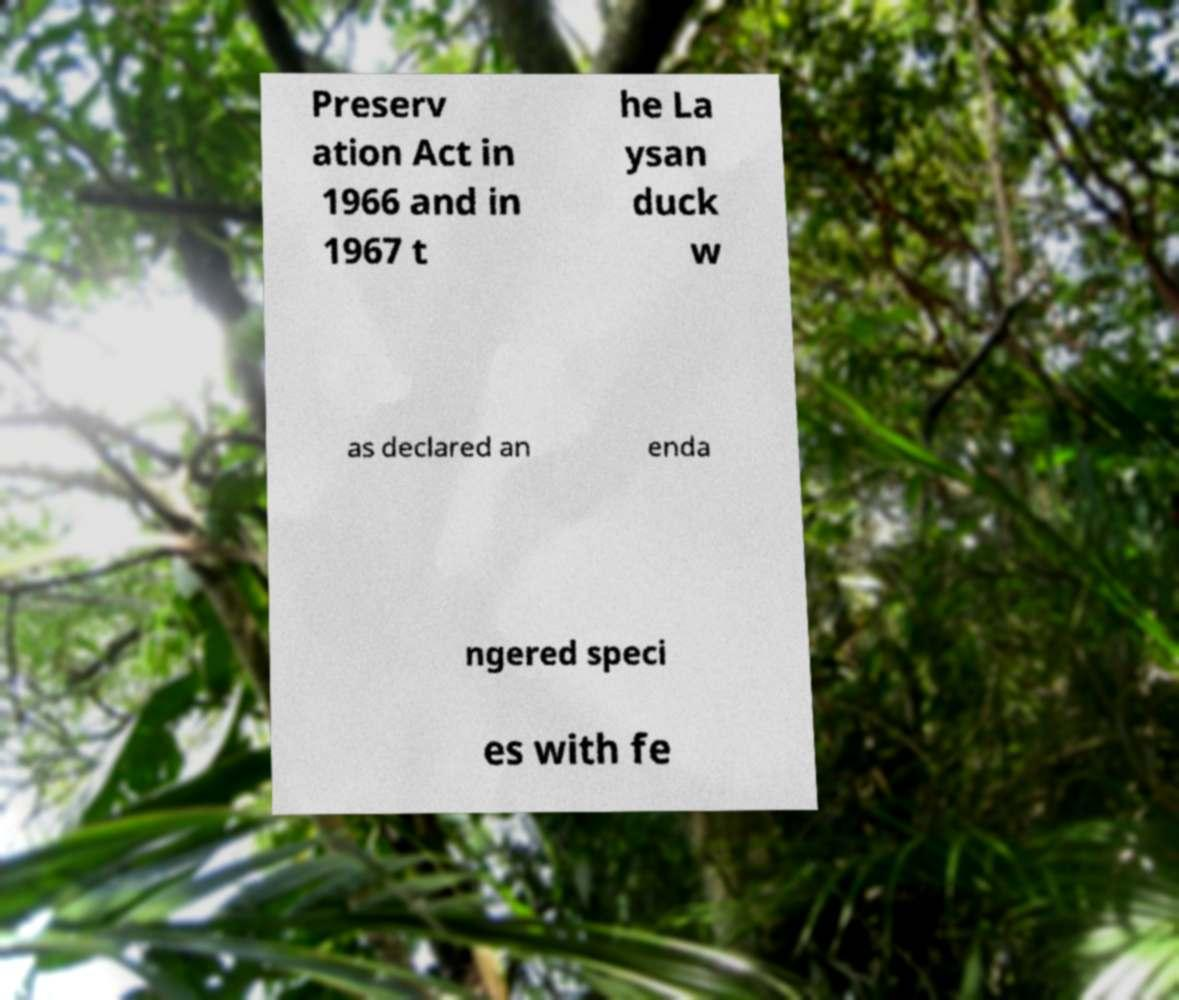There's text embedded in this image that I need extracted. Can you transcribe it verbatim? Preserv ation Act in 1966 and in 1967 t he La ysan duck w as declared an enda ngered speci es with fe 